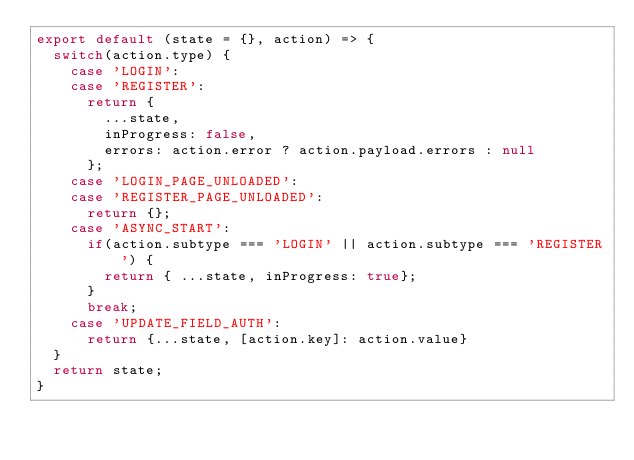<code> <loc_0><loc_0><loc_500><loc_500><_JavaScript_>export default (state = {}, action) => {
  switch(action.type) {
    case 'LOGIN':
    case 'REGISTER':
      return {
        ...state,
        inProgress: false,
        errors: action.error ? action.payload.errors : null
      };
    case 'LOGIN_PAGE_UNLOADED':
    case 'REGISTER_PAGE_UNLOADED':
      return {};
    case 'ASYNC_START':
      if(action.subtype === 'LOGIN' || action.subtype === 'REGISTER') {
        return { ...state, inProgress: true};
      }
      break;
    case 'UPDATE_FIELD_AUTH':
      return {...state, [action.key]: action.value}
  }
  return state;
}</code> 